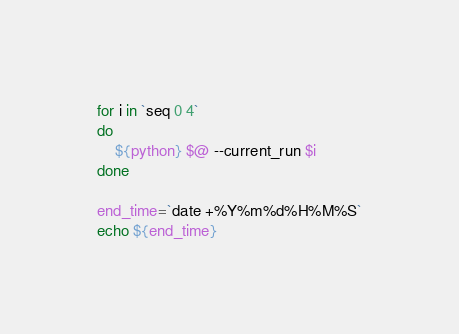<code> <loc_0><loc_0><loc_500><loc_500><_Bash_>
for i in `seq 0 4`
do
	${python} $@ --current_run $i
done

end_time=`date +%Y%m%d%H%M%S`
echo ${end_time}
</code> 